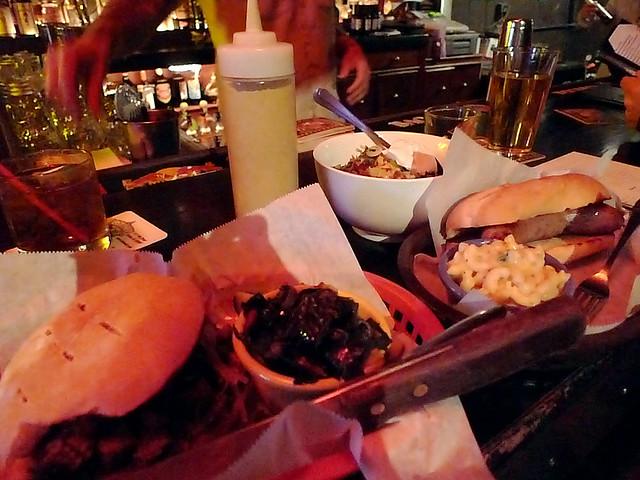What kind of food are served?
Concise answer only. Hot dogs. What is in the bottle?
Keep it brief. Mustard. How many calories in the dish?
Short answer required. 1500. Which food was made from grain?
Be succinct. Bread. 